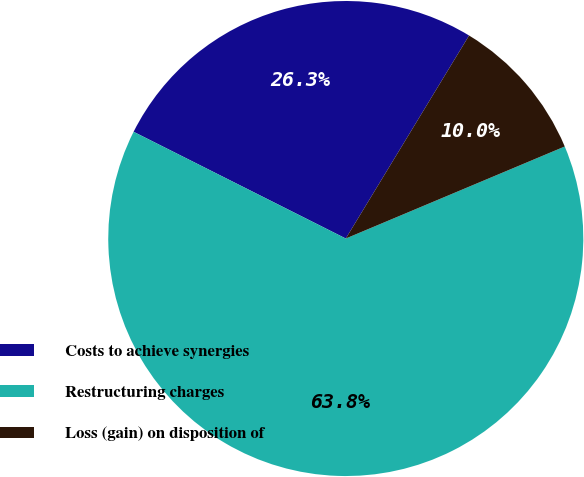Convert chart. <chart><loc_0><loc_0><loc_500><loc_500><pie_chart><fcel>Costs to achieve synergies<fcel>Restructuring charges<fcel>Loss (gain) on disposition of<nl><fcel>26.27%<fcel>63.75%<fcel>9.98%<nl></chart> 